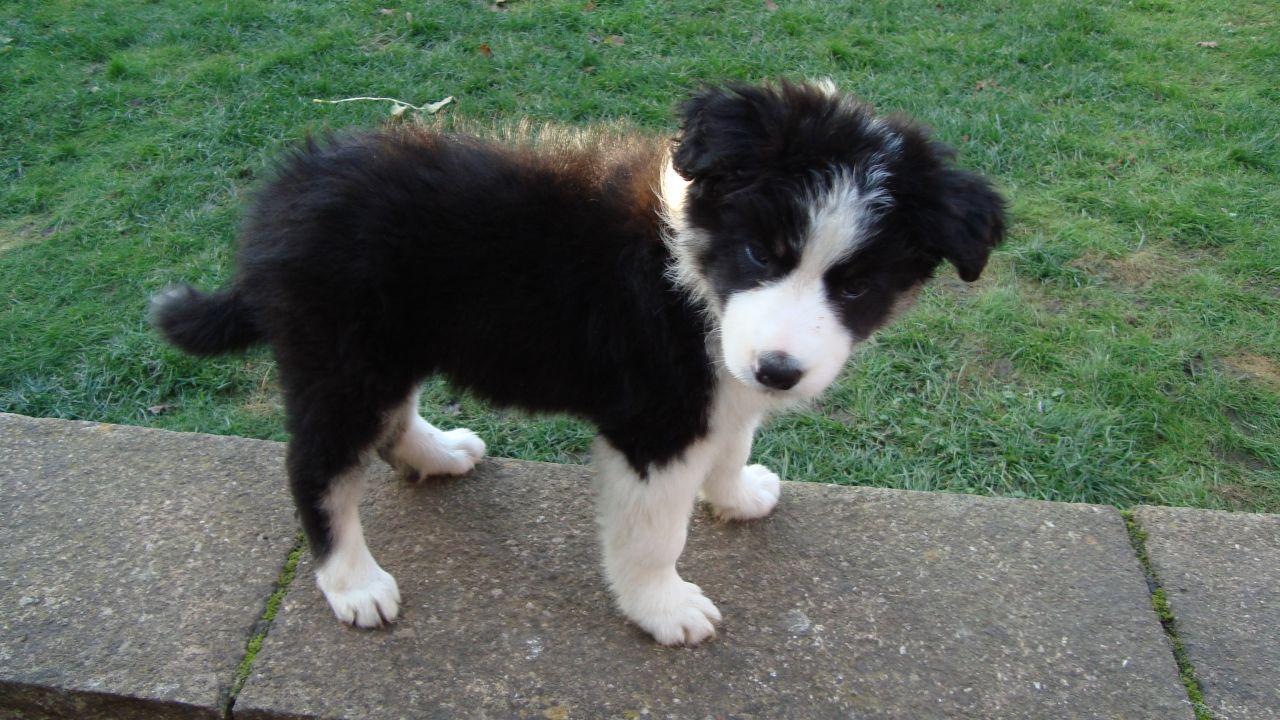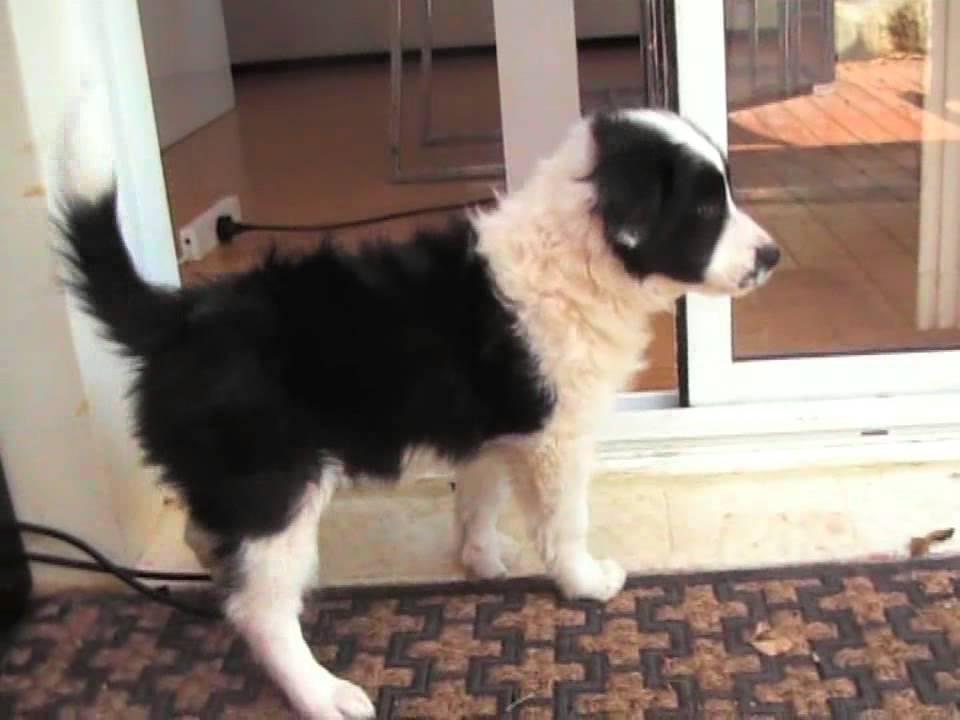The first image is the image on the left, the second image is the image on the right. Assess this claim about the two images: "One of the pups is on the sidewalk.". Correct or not? Answer yes or no. Yes. The first image is the image on the left, the second image is the image on the right. Assess this claim about the two images: "All of the dogs are sitting.". Correct or not? Answer yes or no. No. 